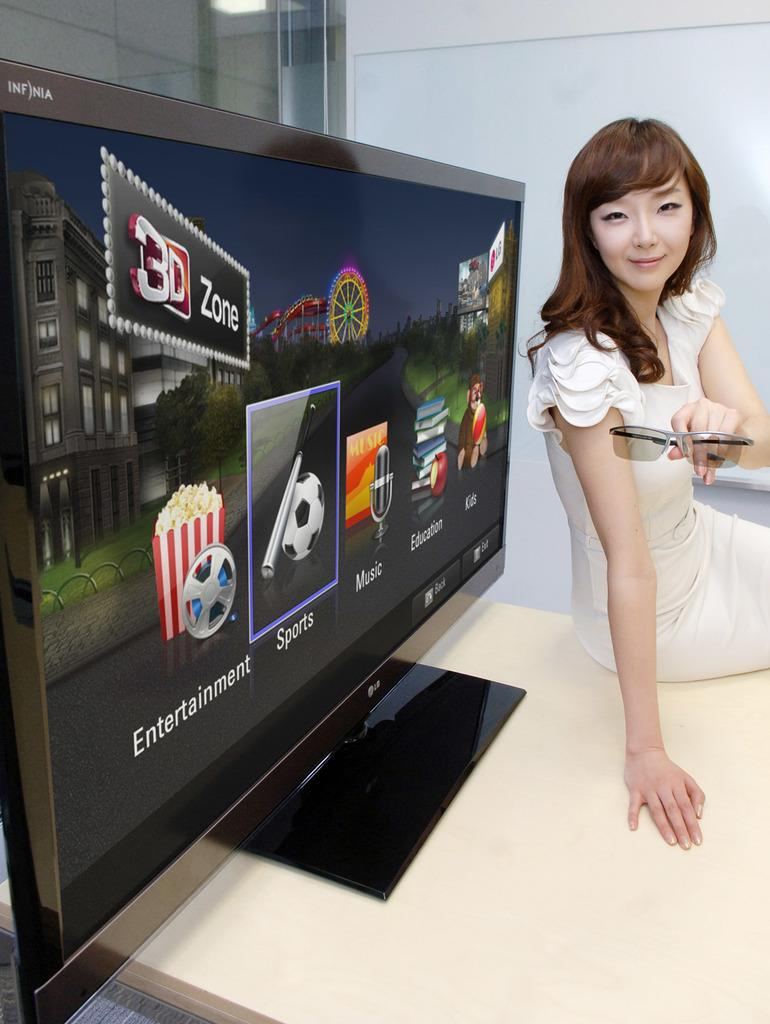What is the main object in the center of the image? There is a TV in the center of the image. Where is the TV placed? The TV is on a table. What is the lady in the image doing? The lady is holding sunglasses. What can be seen in the background of the image? There is a wall in the background of the image. Can you tell me how many bees are flying around the TV in the image? There are no bees present in the image; the focus is on the TV, the lady, and the wall in the background. 